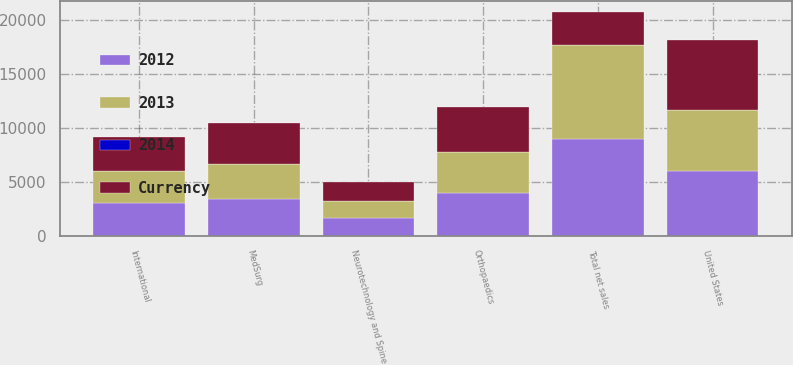Convert chart to OTSL. <chart><loc_0><loc_0><loc_500><loc_500><stacked_bar_chart><ecel><fcel>United States<fcel>International<fcel>Total net sales<fcel>Orthopaedics<fcel>MedSurg<fcel>Neurotechnology and Spine<nl><fcel>Currency<fcel>6558<fcel>3117<fcel>3117<fcel>4153<fcel>3781<fcel>1741<nl><fcel>2012<fcel>5984<fcel>3037<fcel>9021<fcel>3949<fcel>3414<fcel>1658<nl><fcel>2013<fcel>5658<fcel>2999<fcel>8657<fcel>3823<fcel>3265<fcel>1569<nl><fcel>2014<fcel>9.6<fcel>2.6<fcel>7.3<fcel>5.2<fcel>10.8<fcel>5<nl></chart> 